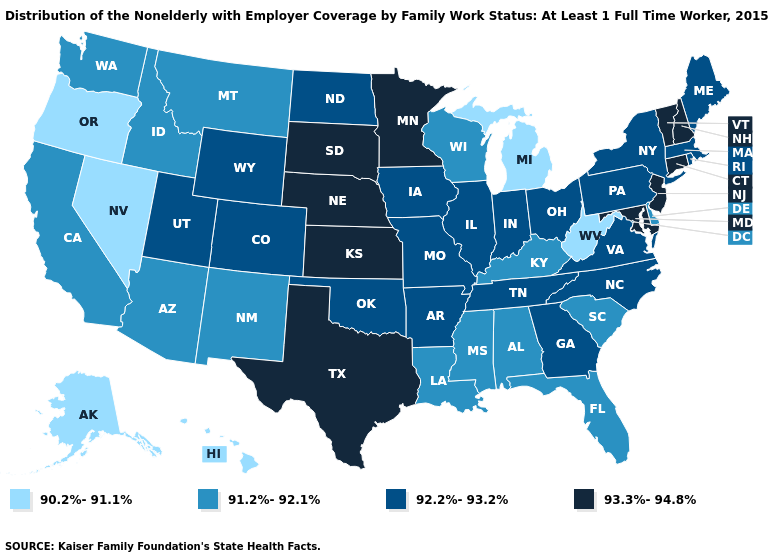Among the states that border Utah , which have the lowest value?
Keep it brief. Nevada. Does Maine have a higher value than Washington?
Answer briefly. Yes. Name the states that have a value in the range 92.2%-93.2%?
Write a very short answer. Arkansas, Colorado, Georgia, Illinois, Indiana, Iowa, Maine, Massachusetts, Missouri, New York, North Carolina, North Dakota, Ohio, Oklahoma, Pennsylvania, Rhode Island, Tennessee, Utah, Virginia, Wyoming. What is the lowest value in the Northeast?
Quick response, please. 92.2%-93.2%. Name the states that have a value in the range 93.3%-94.8%?
Short answer required. Connecticut, Kansas, Maryland, Minnesota, Nebraska, New Hampshire, New Jersey, South Dakota, Texas, Vermont. Which states have the highest value in the USA?
Give a very brief answer. Connecticut, Kansas, Maryland, Minnesota, Nebraska, New Hampshire, New Jersey, South Dakota, Texas, Vermont. Among the states that border Maine , which have the highest value?
Write a very short answer. New Hampshire. Name the states that have a value in the range 91.2%-92.1%?
Quick response, please. Alabama, Arizona, California, Delaware, Florida, Idaho, Kentucky, Louisiana, Mississippi, Montana, New Mexico, South Carolina, Washington, Wisconsin. What is the value of South Carolina?
Concise answer only. 91.2%-92.1%. Which states have the highest value in the USA?
Short answer required. Connecticut, Kansas, Maryland, Minnesota, Nebraska, New Hampshire, New Jersey, South Dakota, Texas, Vermont. Name the states that have a value in the range 93.3%-94.8%?
Keep it brief. Connecticut, Kansas, Maryland, Minnesota, Nebraska, New Hampshire, New Jersey, South Dakota, Texas, Vermont. Does Florida have the highest value in the South?
Quick response, please. No. Which states hav the highest value in the MidWest?
Concise answer only. Kansas, Minnesota, Nebraska, South Dakota. Does the first symbol in the legend represent the smallest category?
Write a very short answer. Yes. What is the value of Hawaii?
Be succinct. 90.2%-91.1%. 